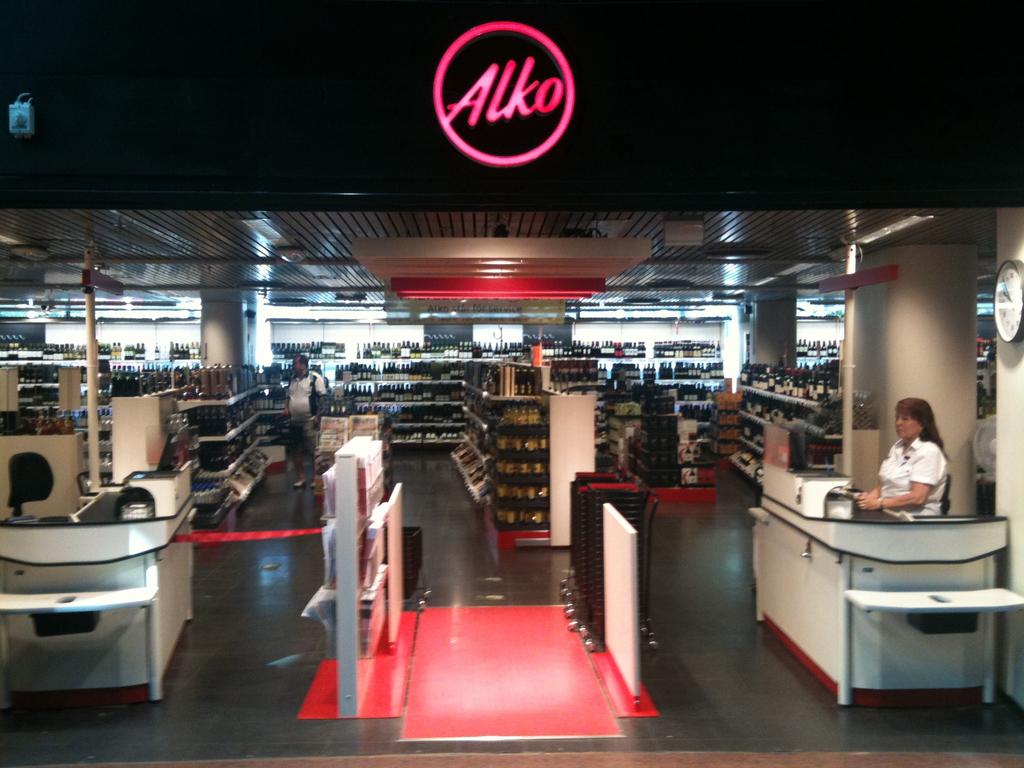What does the red letters say?
Your answer should be compact. Alko. 